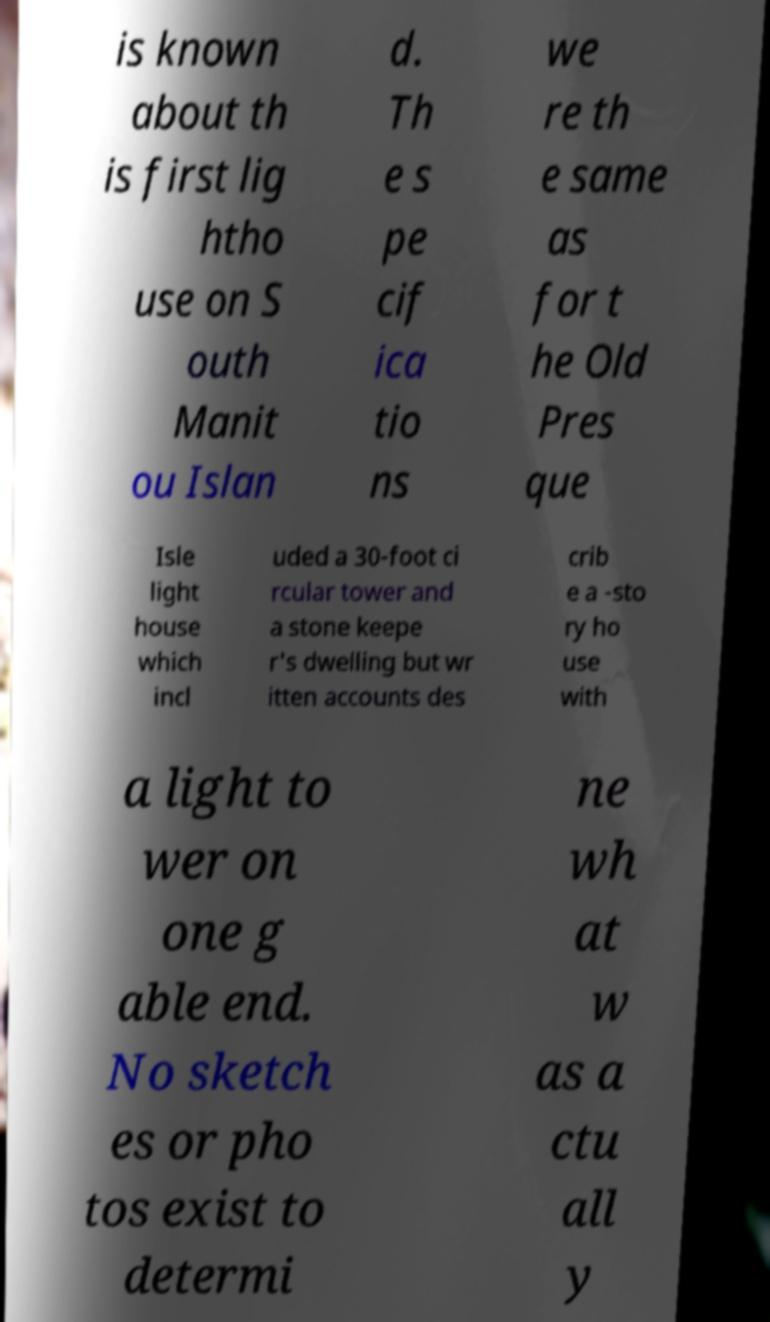For documentation purposes, I need the text within this image transcribed. Could you provide that? is known about th is first lig htho use on S outh Manit ou Islan d. Th e s pe cif ica tio ns we re th e same as for t he Old Pres que Isle light house which incl uded a 30-foot ci rcular tower and a stone keepe r's dwelling but wr itten accounts des crib e a -sto ry ho use with a light to wer on one g able end. No sketch es or pho tos exist to determi ne wh at w as a ctu all y 